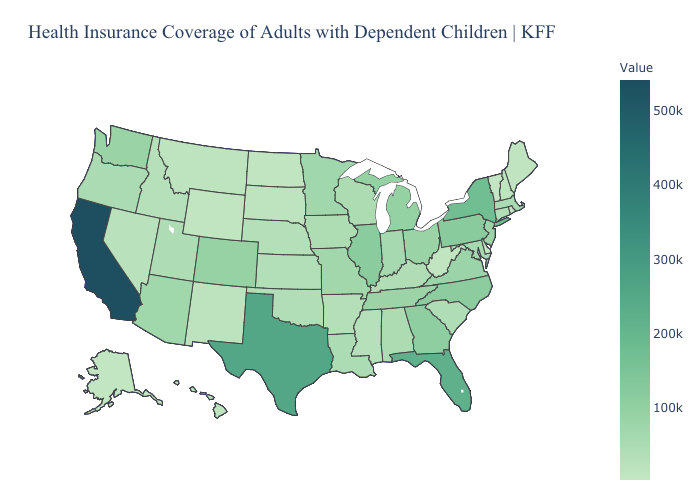Does Delaware have a higher value than North Carolina?
Short answer required. No. Does the map have missing data?
Be succinct. No. Among the states that border Massachusetts , which have the highest value?
Be succinct. New York. Does the map have missing data?
Short answer required. No. Does Illinois have the highest value in the MidWest?
Answer briefly. Yes. 